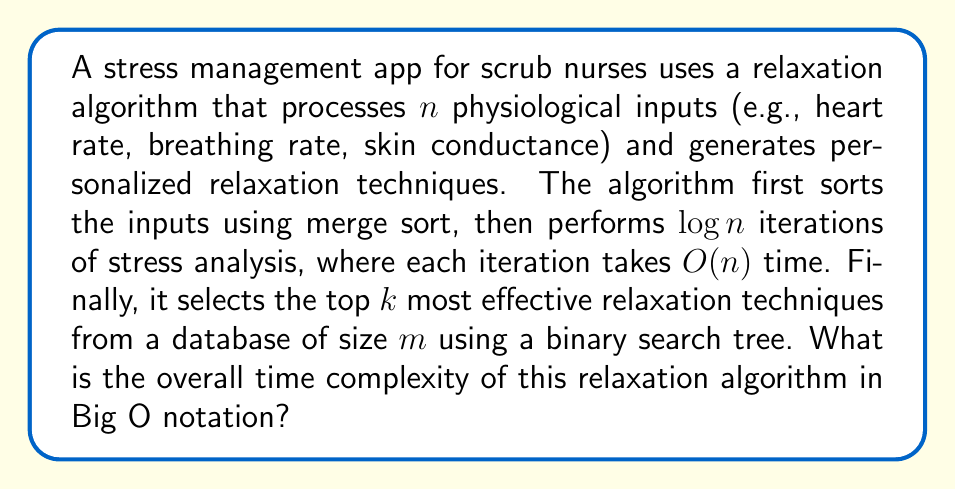Show me your answer to this math problem. To determine the overall time complexity, let's break down the algorithm into its components:

1. Sorting inputs using merge sort:
   - Merge sort has a time complexity of $O(n \log n)$

2. Stress analysis iterations:
   - $\log n$ iterations, each taking $O(n)$ time
   - Total time for this step: $O(n \log n)$

3. Selecting top $k$ relaxation techniques:
   - Using a binary search tree with $m$ elements
   - Time complexity for searching and selecting $k$ elements: $O(k \log m)$

Now, let's combine these components:

$$T(n, m, k) = O(n \log n) + O(n \log n) + O(k \log m)$$

Simplifying:
$$T(n, m, k) = O(n \log n + k \log m)$$

Since $k$ and $m$ are independent of $n$, and assuming $k \leq n$ and $m \leq n$ (as the number of relaxation techniques is likely not larger than the number of inputs), we can simplify further:

$$T(n) = O(n \log n)$$

This is because $n \log n$ dominates $k \log m$ under these assumptions.
Answer: $O(n \log n)$ 